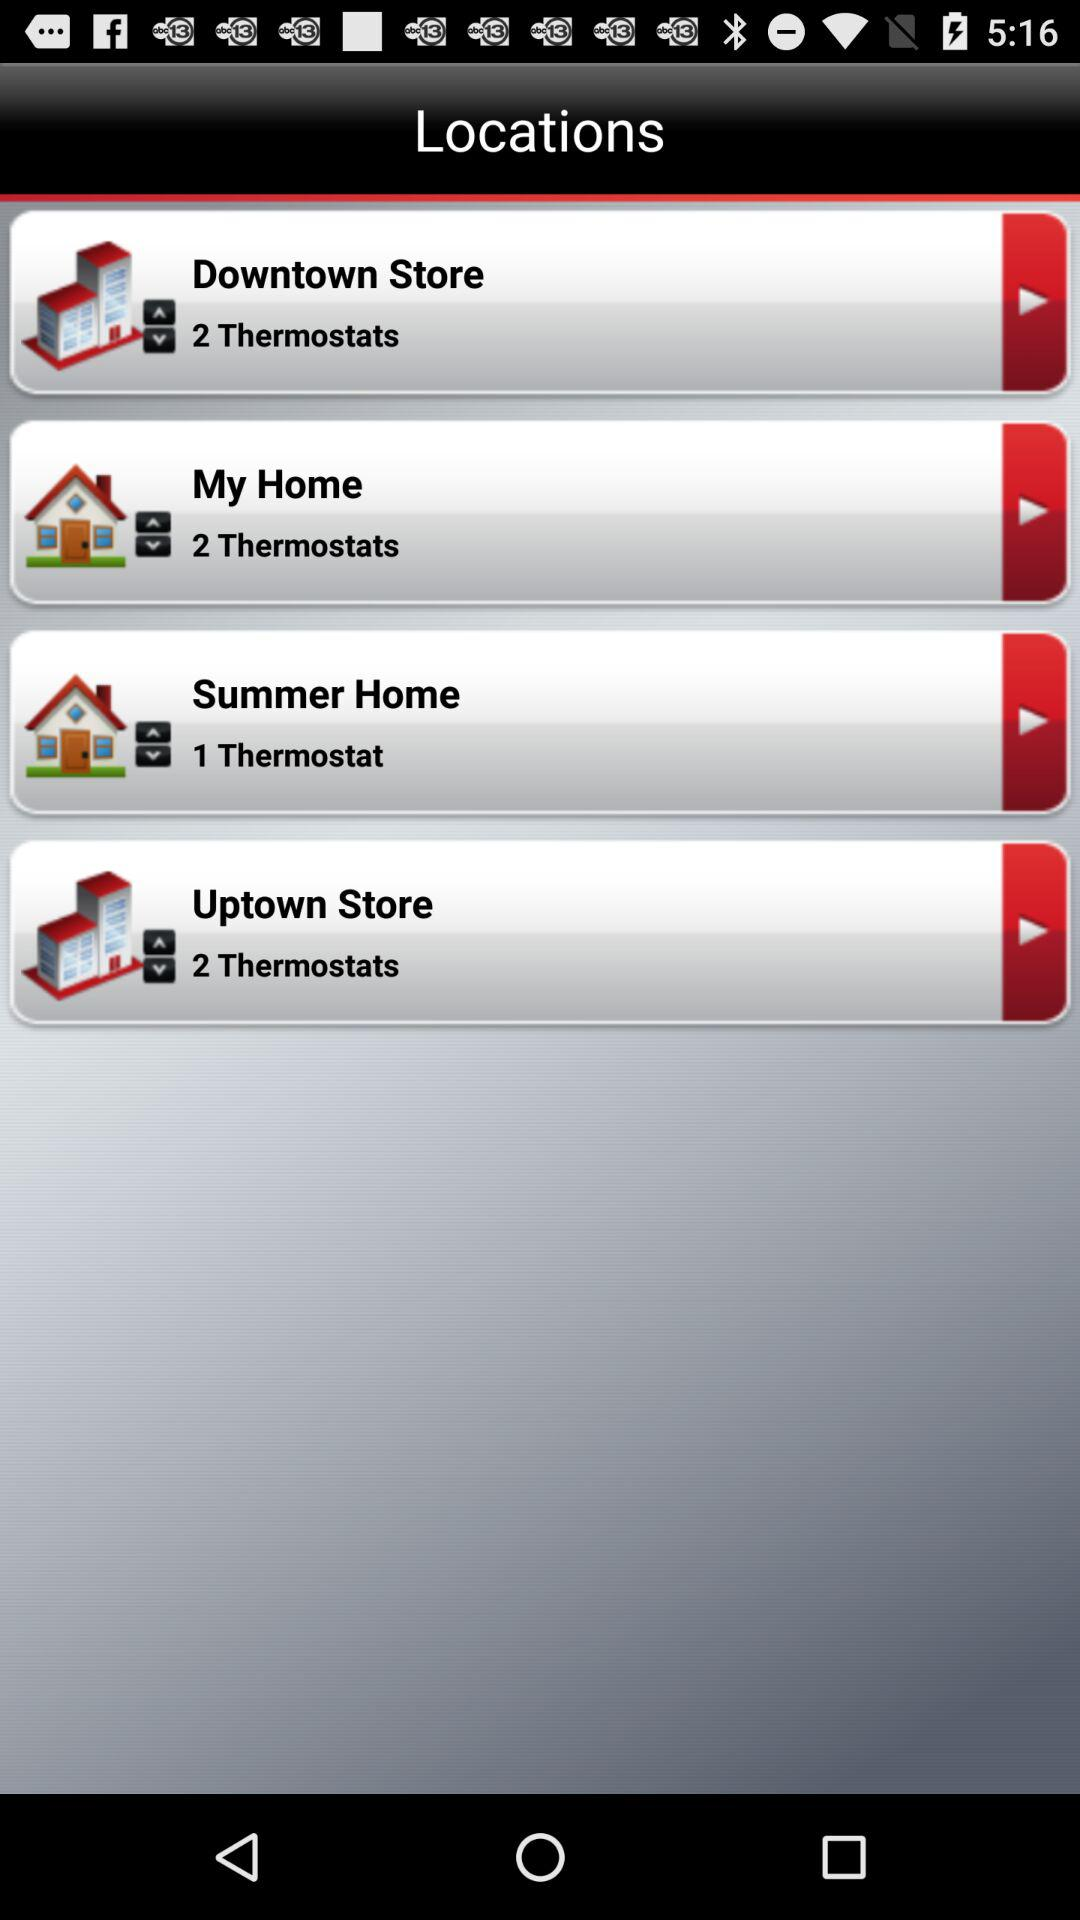My home is located at which thermostats? It is located at 2 thermostats. 